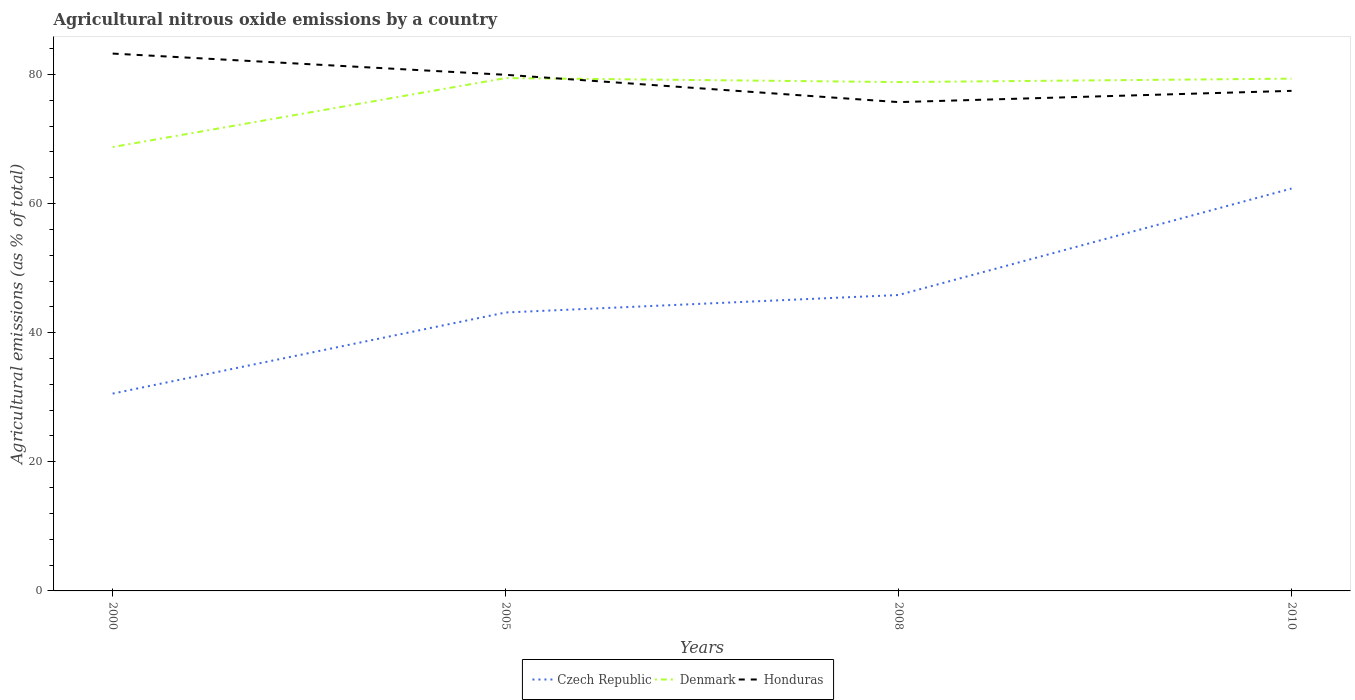How many different coloured lines are there?
Offer a terse response. 3. Does the line corresponding to Honduras intersect with the line corresponding to Denmark?
Keep it short and to the point. Yes. Is the number of lines equal to the number of legend labels?
Your answer should be compact. Yes. Across all years, what is the maximum amount of agricultural nitrous oxide emitted in Denmark?
Offer a terse response. 68.76. In which year was the amount of agricultural nitrous oxide emitted in Czech Republic maximum?
Your answer should be very brief. 2000. What is the total amount of agricultural nitrous oxide emitted in Honduras in the graph?
Your answer should be very brief. 3.29. What is the difference between the highest and the second highest amount of agricultural nitrous oxide emitted in Honduras?
Keep it short and to the point. 7.52. What is the difference between the highest and the lowest amount of agricultural nitrous oxide emitted in Denmark?
Offer a very short reply. 3. Is the amount of agricultural nitrous oxide emitted in Denmark strictly greater than the amount of agricultural nitrous oxide emitted in Czech Republic over the years?
Your response must be concise. No. How many lines are there?
Ensure brevity in your answer.  3. How many years are there in the graph?
Your response must be concise. 4. Does the graph contain any zero values?
Offer a terse response. No. How many legend labels are there?
Your answer should be compact. 3. How are the legend labels stacked?
Ensure brevity in your answer.  Horizontal. What is the title of the graph?
Offer a very short reply. Agricultural nitrous oxide emissions by a country. Does "Zambia" appear as one of the legend labels in the graph?
Make the answer very short. No. What is the label or title of the X-axis?
Your answer should be compact. Years. What is the label or title of the Y-axis?
Give a very brief answer. Agricultural emissions (as % of total). What is the Agricultural emissions (as % of total) of Czech Republic in 2000?
Your response must be concise. 30.56. What is the Agricultural emissions (as % of total) of Denmark in 2000?
Offer a terse response. 68.76. What is the Agricultural emissions (as % of total) of Honduras in 2000?
Ensure brevity in your answer.  83.23. What is the Agricultural emissions (as % of total) in Czech Republic in 2005?
Your answer should be compact. 43.13. What is the Agricultural emissions (as % of total) in Denmark in 2005?
Make the answer very short. 79.44. What is the Agricultural emissions (as % of total) of Honduras in 2005?
Your answer should be compact. 79.95. What is the Agricultural emissions (as % of total) in Czech Republic in 2008?
Your response must be concise. 45.84. What is the Agricultural emissions (as % of total) in Denmark in 2008?
Your response must be concise. 78.82. What is the Agricultural emissions (as % of total) of Honduras in 2008?
Ensure brevity in your answer.  75.72. What is the Agricultural emissions (as % of total) in Czech Republic in 2010?
Your response must be concise. 62.33. What is the Agricultural emissions (as % of total) of Denmark in 2010?
Offer a very short reply. 79.35. What is the Agricultural emissions (as % of total) in Honduras in 2010?
Give a very brief answer. 77.46. Across all years, what is the maximum Agricultural emissions (as % of total) of Czech Republic?
Give a very brief answer. 62.33. Across all years, what is the maximum Agricultural emissions (as % of total) of Denmark?
Your answer should be very brief. 79.44. Across all years, what is the maximum Agricultural emissions (as % of total) of Honduras?
Your answer should be compact. 83.23. Across all years, what is the minimum Agricultural emissions (as % of total) in Czech Republic?
Offer a terse response. 30.56. Across all years, what is the minimum Agricultural emissions (as % of total) of Denmark?
Give a very brief answer. 68.76. Across all years, what is the minimum Agricultural emissions (as % of total) in Honduras?
Your response must be concise. 75.72. What is the total Agricultural emissions (as % of total) in Czech Republic in the graph?
Your response must be concise. 181.86. What is the total Agricultural emissions (as % of total) of Denmark in the graph?
Provide a short and direct response. 306.37. What is the total Agricultural emissions (as % of total) in Honduras in the graph?
Give a very brief answer. 316.36. What is the difference between the Agricultural emissions (as % of total) in Czech Republic in 2000 and that in 2005?
Your answer should be compact. -12.57. What is the difference between the Agricultural emissions (as % of total) of Denmark in 2000 and that in 2005?
Your answer should be very brief. -10.68. What is the difference between the Agricultural emissions (as % of total) in Honduras in 2000 and that in 2005?
Keep it short and to the point. 3.29. What is the difference between the Agricultural emissions (as % of total) in Czech Republic in 2000 and that in 2008?
Keep it short and to the point. -15.27. What is the difference between the Agricultural emissions (as % of total) in Denmark in 2000 and that in 2008?
Provide a short and direct response. -10.06. What is the difference between the Agricultural emissions (as % of total) of Honduras in 2000 and that in 2008?
Your answer should be very brief. 7.52. What is the difference between the Agricultural emissions (as % of total) in Czech Republic in 2000 and that in 2010?
Offer a very short reply. -31.77. What is the difference between the Agricultural emissions (as % of total) of Denmark in 2000 and that in 2010?
Provide a succinct answer. -10.59. What is the difference between the Agricultural emissions (as % of total) of Honduras in 2000 and that in 2010?
Offer a very short reply. 5.77. What is the difference between the Agricultural emissions (as % of total) of Czech Republic in 2005 and that in 2008?
Offer a very short reply. -2.71. What is the difference between the Agricultural emissions (as % of total) in Denmark in 2005 and that in 2008?
Ensure brevity in your answer.  0.62. What is the difference between the Agricultural emissions (as % of total) of Honduras in 2005 and that in 2008?
Ensure brevity in your answer.  4.23. What is the difference between the Agricultural emissions (as % of total) of Czech Republic in 2005 and that in 2010?
Offer a very short reply. -19.2. What is the difference between the Agricultural emissions (as % of total) of Denmark in 2005 and that in 2010?
Your answer should be compact. 0.09. What is the difference between the Agricultural emissions (as % of total) of Honduras in 2005 and that in 2010?
Your response must be concise. 2.49. What is the difference between the Agricultural emissions (as % of total) of Czech Republic in 2008 and that in 2010?
Offer a terse response. -16.49. What is the difference between the Agricultural emissions (as % of total) of Denmark in 2008 and that in 2010?
Your answer should be compact. -0.53. What is the difference between the Agricultural emissions (as % of total) in Honduras in 2008 and that in 2010?
Provide a short and direct response. -1.74. What is the difference between the Agricultural emissions (as % of total) of Czech Republic in 2000 and the Agricultural emissions (as % of total) of Denmark in 2005?
Give a very brief answer. -48.88. What is the difference between the Agricultural emissions (as % of total) of Czech Republic in 2000 and the Agricultural emissions (as % of total) of Honduras in 2005?
Offer a very short reply. -49.38. What is the difference between the Agricultural emissions (as % of total) in Denmark in 2000 and the Agricultural emissions (as % of total) in Honduras in 2005?
Provide a short and direct response. -11.19. What is the difference between the Agricultural emissions (as % of total) in Czech Republic in 2000 and the Agricultural emissions (as % of total) in Denmark in 2008?
Keep it short and to the point. -48.25. What is the difference between the Agricultural emissions (as % of total) of Czech Republic in 2000 and the Agricultural emissions (as % of total) of Honduras in 2008?
Your answer should be compact. -45.15. What is the difference between the Agricultural emissions (as % of total) in Denmark in 2000 and the Agricultural emissions (as % of total) in Honduras in 2008?
Provide a short and direct response. -6.96. What is the difference between the Agricultural emissions (as % of total) of Czech Republic in 2000 and the Agricultural emissions (as % of total) of Denmark in 2010?
Offer a very short reply. -48.79. What is the difference between the Agricultural emissions (as % of total) of Czech Republic in 2000 and the Agricultural emissions (as % of total) of Honduras in 2010?
Give a very brief answer. -46.9. What is the difference between the Agricultural emissions (as % of total) in Denmark in 2000 and the Agricultural emissions (as % of total) in Honduras in 2010?
Keep it short and to the point. -8.7. What is the difference between the Agricultural emissions (as % of total) in Czech Republic in 2005 and the Agricultural emissions (as % of total) in Denmark in 2008?
Make the answer very short. -35.69. What is the difference between the Agricultural emissions (as % of total) of Czech Republic in 2005 and the Agricultural emissions (as % of total) of Honduras in 2008?
Offer a very short reply. -32.59. What is the difference between the Agricultural emissions (as % of total) of Denmark in 2005 and the Agricultural emissions (as % of total) of Honduras in 2008?
Ensure brevity in your answer.  3.72. What is the difference between the Agricultural emissions (as % of total) in Czech Republic in 2005 and the Agricultural emissions (as % of total) in Denmark in 2010?
Provide a short and direct response. -36.22. What is the difference between the Agricultural emissions (as % of total) of Czech Republic in 2005 and the Agricultural emissions (as % of total) of Honduras in 2010?
Offer a terse response. -34.33. What is the difference between the Agricultural emissions (as % of total) in Denmark in 2005 and the Agricultural emissions (as % of total) in Honduras in 2010?
Provide a short and direct response. 1.98. What is the difference between the Agricultural emissions (as % of total) in Czech Republic in 2008 and the Agricultural emissions (as % of total) in Denmark in 2010?
Your answer should be very brief. -33.51. What is the difference between the Agricultural emissions (as % of total) of Czech Republic in 2008 and the Agricultural emissions (as % of total) of Honduras in 2010?
Offer a very short reply. -31.62. What is the difference between the Agricultural emissions (as % of total) of Denmark in 2008 and the Agricultural emissions (as % of total) of Honduras in 2010?
Give a very brief answer. 1.36. What is the average Agricultural emissions (as % of total) in Czech Republic per year?
Offer a very short reply. 45.47. What is the average Agricultural emissions (as % of total) in Denmark per year?
Keep it short and to the point. 76.59. What is the average Agricultural emissions (as % of total) of Honduras per year?
Keep it short and to the point. 79.09. In the year 2000, what is the difference between the Agricultural emissions (as % of total) of Czech Republic and Agricultural emissions (as % of total) of Denmark?
Your answer should be compact. -38.19. In the year 2000, what is the difference between the Agricultural emissions (as % of total) in Czech Republic and Agricultural emissions (as % of total) in Honduras?
Give a very brief answer. -52.67. In the year 2000, what is the difference between the Agricultural emissions (as % of total) in Denmark and Agricultural emissions (as % of total) in Honduras?
Your answer should be very brief. -14.48. In the year 2005, what is the difference between the Agricultural emissions (as % of total) in Czech Republic and Agricultural emissions (as % of total) in Denmark?
Your answer should be compact. -36.31. In the year 2005, what is the difference between the Agricultural emissions (as % of total) in Czech Republic and Agricultural emissions (as % of total) in Honduras?
Provide a short and direct response. -36.82. In the year 2005, what is the difference between the Agricultural emissions (as % of total) in Denmark and Agricultural emissions (as % of total) in Honduras?
Provide a succinct answer. -0.51. In the year 2008, what is the difference between the Agricultural emissions (as % of total) of Czech Republic and Agricultural emissions (as % of total) of Denmark?
Provide a succinct answer. -32.98. In the year 2008, what is the difference between the Agricultural emissions (as % of total) of Czech Republic and Agricultural emissions (as % of total) of Honduras?
Offer a very short reply. -29.88. In the year 2008, what is the difference between the Agricultural emissions (as % of total) of Denmark and Agricultural emissions (as % of total) of Honduras?
Provide a short and direct response. 3.1. In the year 2010, what is the difference between the Agricultural emissions (as % of total) in Czech Republic and Agricultural emissions (as % of total) in Denmark?
Offer a very short reply. -17.02. In the year 2010, what is the difference between the Agricultural emissions (as % of total) of Czech Republic and Agricultural emissions (as % of total) of Honduras?
Keep it short and to the point. -15.13. In the year 2010, what is the difference between the Agricultural emissions (as % of total) of Denmark and Agricultural emissions (as % of total) of Honduras?
Make the answer very short. 1.89. What is the ratio of the Agricultural emissions (as % of total) of Czech Republic in 2000 to that in 2005?
Ensure brevity in your answer.  0.71. What is the ratio of the Agricultural emissions (as % of total) in Denmark in 2000 to that in 2005?
Offer a very short reply. 0.87. What is the ratio of the Agricultural emissions (as % of total) in Honduras in 2000 to that in 2005?
Your answer should be very brief. 1.04. What is the ratio of the Agricultural emissions (as % of total) in Czech Republic in 2000 to that in 2008?
Offer a very short reply. 0.67. What is the ratio of the Agricultural emissions (as % of total) of Denmark in 2000 to that in 2008?
Your answer should be compact. 0.87. What is the ratio of the Agricultural emissions (as % of total) of Honduras in 2000 to that in 2008?
Keep it short and to the point. 1.1. What is the ratio of the Agricultural emissions (as % of total) of Czech Republic in 2000 to that in 2010?
Your response must be concise. 0.49. What is the ratio of the Agricultural emissions (as % of total) in Denmark in 2000 to that in 2010?
Your response must be concise. 0.87. What is the ratio of the Agricultural emissions (as % of total) of Honduras in 2000 to that in 2010?
Provide a succinct answer. 1.07. What is the ratio of the Agricultural emissions (as % of total) in Czech Republic in 2005 to that in 2008?
Make the answer very short. 0.94. What is the ratio of the Agricultural emissions (as % of total) of Denmark in 2005 to that in 2008?
Give a very brief answer. 1.01. What is the ratio of the Agricultural emissions (as % of total) of Honduras in 2005 to that in 2008?
Offer a very short reply. 1.06. What is the ratio of the Agricultural emissions (as % of total) in Czech Republic in 2005 to that in 2010?
Make the answer very short. 0.69. What is the ratio of the Agricultural emissions (as % of total) in Denmark in 2005 to that in 2010?
Your response must be concise. 1. What is the ratio of the Agricultural emissions (as % of total) in Honduras in 2005 to that in 2010?
Provide a short and direct response. 1.03. What is the ratio of the Agricultural emissions (as % of total) of Czech Republic in 2008 to that in 2010?
Make the answer very short. 0.74. What is the ratio of the Agricultural emissions (as % of total) in Honduras in 2008 to that in 2010?
Provide a succinct answer. 0.98. What is the difference between the highest and the second highest Agricultural emissions (as % of total) in Czech Republic?
Your response must be concise. 16.49. What is the difference between the highest and the second highest Agricultural emissions (as % of total) in Denmark?
Offer a terse response. 0.09. What is the difference between the highest and the second highest Agricultural emissions (as % of total) of Honduras?
Offer a terse response. 3.29. What is the difference between the highest and the lowest Agricultural emissions (as % of total) in Czech Republic?
Give a very brief answer. 31.77. What is the difference between the highest and the lowest Agricultural emissions (as % of total) of Denmark?
Give a very brief answer. 10.68. What is the difference between the highest and the lowest Agricultural emissions (as % of total) of Honduras?
Provide a short and direct response. 7.52. 